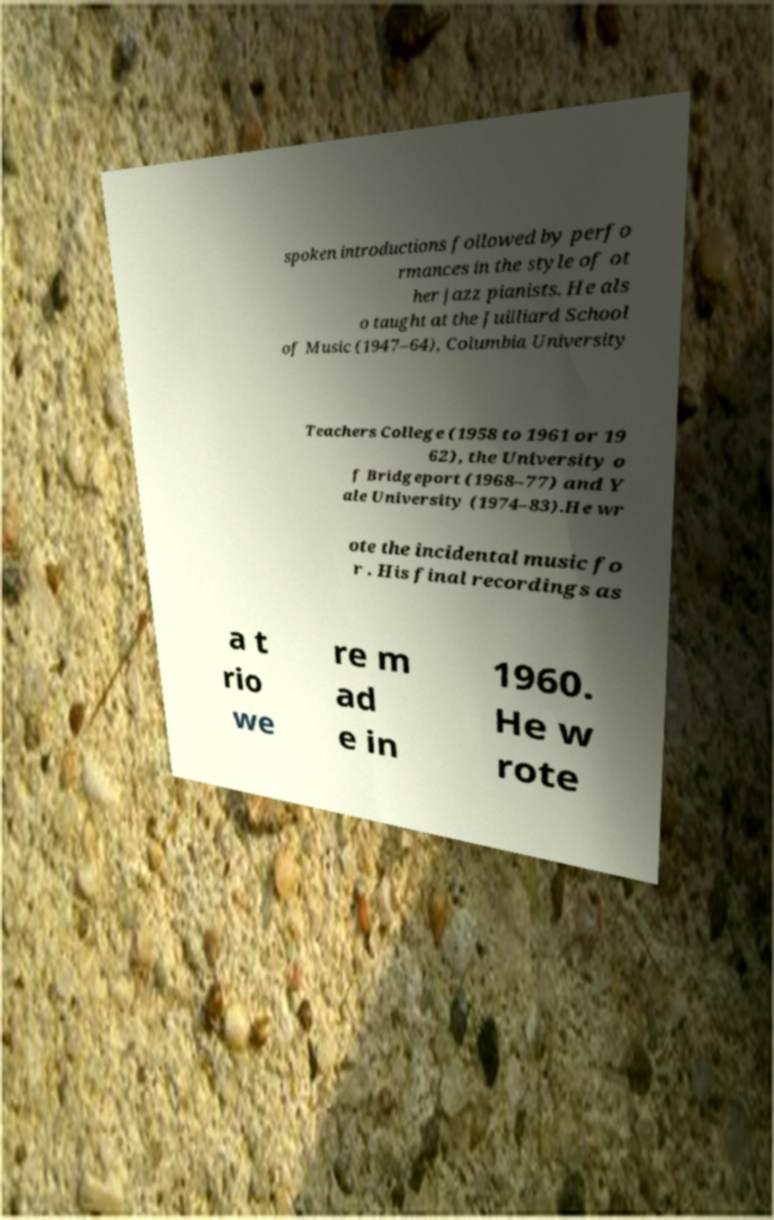I need the written content from this picture converted into text. Can you do that? spoken introductions followed by perfo rmances in the style of ot her jazz pianists. He als o taught at the Juilliard School of Music (1947–64), Columbia University Teachers College (1958 to 1961 or 19 62), the University o f Bridgeport (1968–77) and Y ale University (1974–83).He wr ote the incidental music fo r . His final recordings as a t rio we re m ad e in 1960. He w rote 